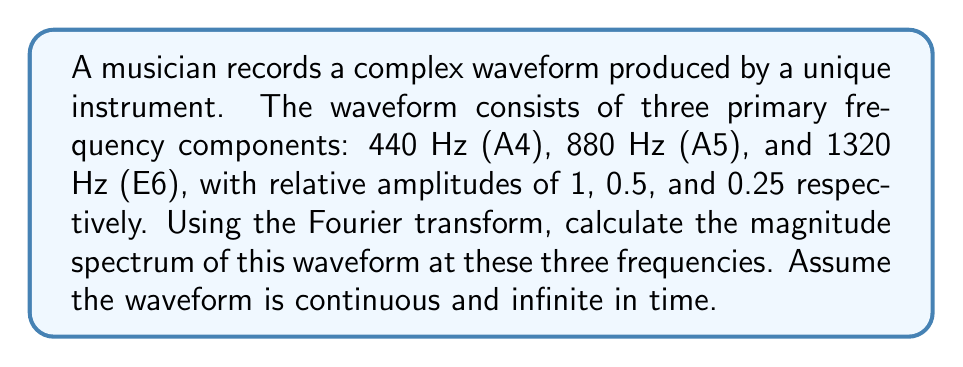Give your solution to this math problem. To analyze the frequency spectrum of this complex waveform using Fourier transforms, we'll follow these steps:

1) The general form of a complex waveform with multiple frequency components is:

   $$x(t) = \sum_{n=1}^N A_n \cos(2\pi f_n t)$$

   where $A_n$ is the amplitude and $f_n$ is the frequency of each component.

2) In this case, we have:

   $$x(t) = 1 \cos(2\pi \cdot 440t) + 0.5 \cos(2\pi \cdot 880t) + 0.25 \cos(2\pi \cdot 1320t)$$

3) The Fourier transform of a cosine function is given by:

   $$\mathcal{F}\{\cos(2\pi f_0 t)\} = \frac{1}{2}[\delta(f-f_0) + \delta(f+f_0)]$$

   where $\delta$ is the Dirac delta function.

4) Applying this to our waveform and using the linearity property of Fourier transforms:

   $$X(f) = \frac{1}{2}[1\delta(f-440) + 1\delta(f+440)] + \frac{1}{4}[0.5\delta(f-880) + 0.5\delta(f+880)] + \frac{1}{8}[0.25\delta(f-1320) + 0.25\delta(f+1320)]$$

5) The magnitude spectrum $|X(f)|$ is the absolute value of $X(f)$. At the positive frequencies:

   At 440 Hz: $|X(440)| = \frac{1}{2} = 0.5$
   At 880 Hz: $|X(880)| = \frac{0.5}{4} = 0.125$
   At 1320 Hz: $|X(1320)| = \frac{0.25}{8} = 0.03125$

These values represent the magnitude of each frequency component in the spectrum.
Answer: $|X(440)| = 0.5$, $|X(880)| = 0.125$, $|X(1320)| = 0.03125$ 